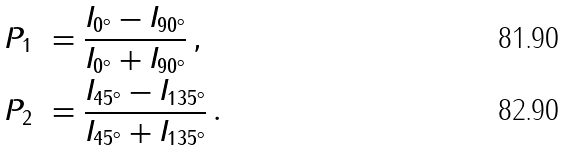Convert formula to latex. <formula><loc_0><loc_0><loc_500><loc_500>P _ { 1 } & \ = \frac { I _ { 0 ^ { \circ } } - I _ { 9 0 ^ { \circ } } } { I _ { 0 ^ { \circ } } + I _ { 9 0 ^ { \circ } } } \, , \\ \ P _ { 2 } & \ = \frac { I _ { 4 5 ^ { \circ } } - I _ { 1 3 5 ^ { \circ } } } { I _ { 4 5 ^ { \circ } } + I _ { 1 3 5 ^ { \circ } } } \, .</formula> 